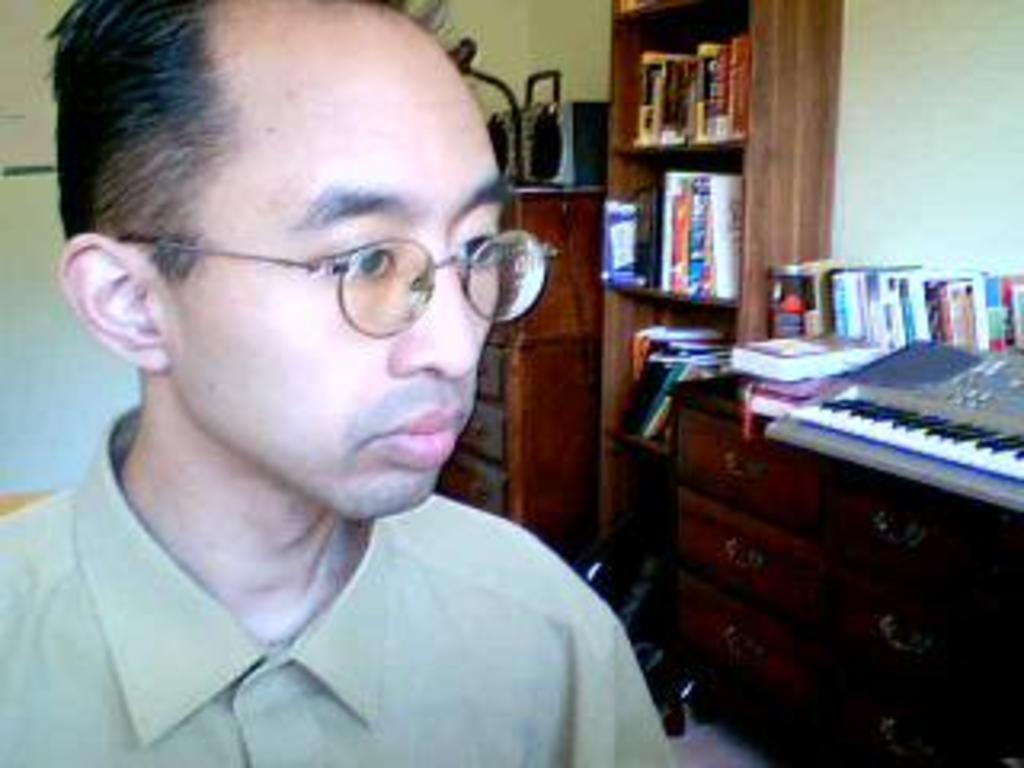Who is present in the image? There is a man in the image. What can be seen in the background of the image? There are books and cupboards in the background of the image. What type of rail can be seen in the maneuvering the basketball in the image? There is no rail or basketball present in the image. 